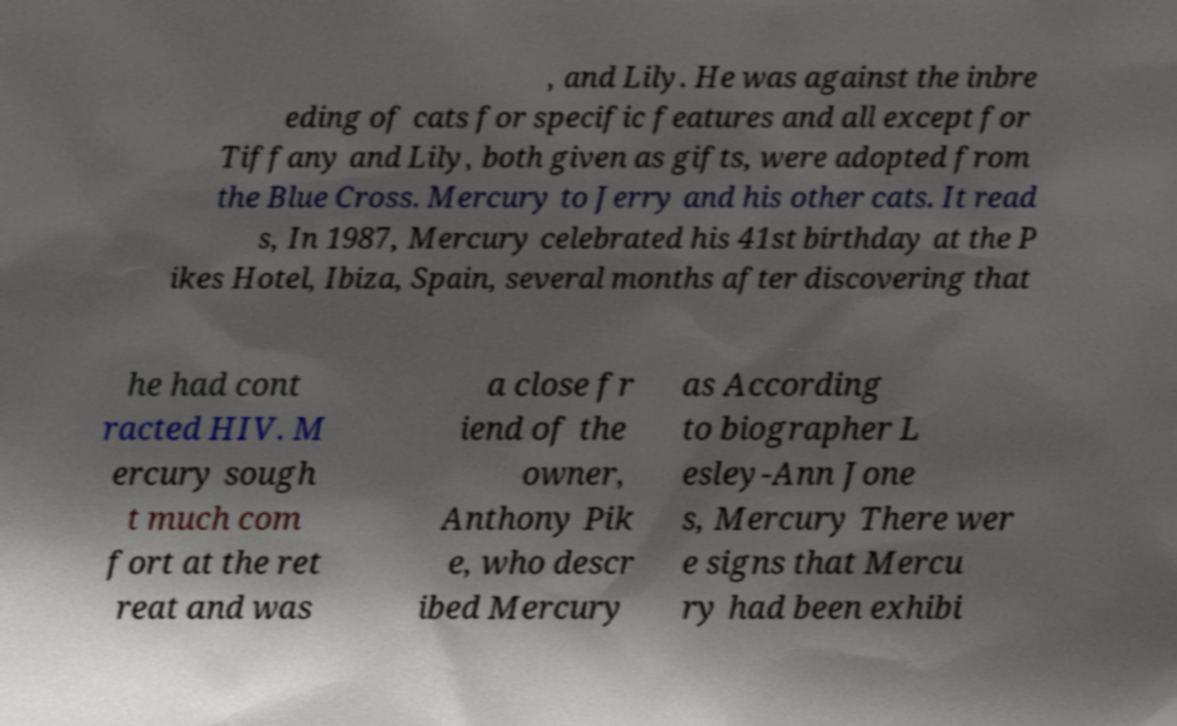Could you assist in decoding the text presented in this image and type it out clearly? , and Lily. He was against the inbre eding of cats for specific features and all except for Tiffany and Lily, both given as gifts, were adopted from the Blue Cross. Mercury to Jerry and his other cats. It read s, In 1987, Mercury celebrated his 41st birthday at the P ikes Hotel, Ibiza, Spain, several months after discovering that he had cont racted HIV. M ercury sough t much com fort at the ret reat and was a close fr iend of the owner, Anthony Pik e, who descr ibed Mercury as According to biographer L esley-Ann Jone s, Mercury There wer e signs that Mercu ry had been exhibi 